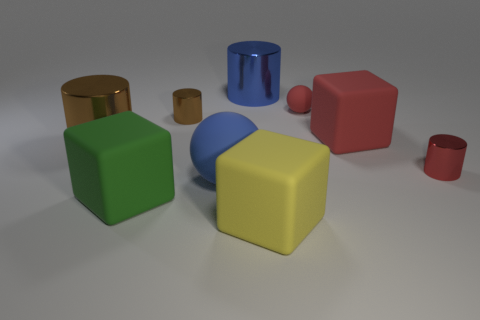Add 1 small cylinders. How many objects exist? 10 Subtract all cylinders. How many objects are left? 5 Subtract 1 blue balls. How many objects are left? 8 Subtract all large brown metal cylinders. Subtract all red balls. How many objects are left? 7 Add 2 red rubber objects. How many red rubber objects are left? 4 Add 5 large green cubes. How many large green cubes exist? 6 